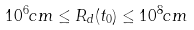<formula> <loc_0><loc_0><loc_500><loc_500>1 0 ^ { 6 } c m \leq R _ { d } ( t _ { 0 } ) \leq 1 0 ^ { 8 } c m</formula> 